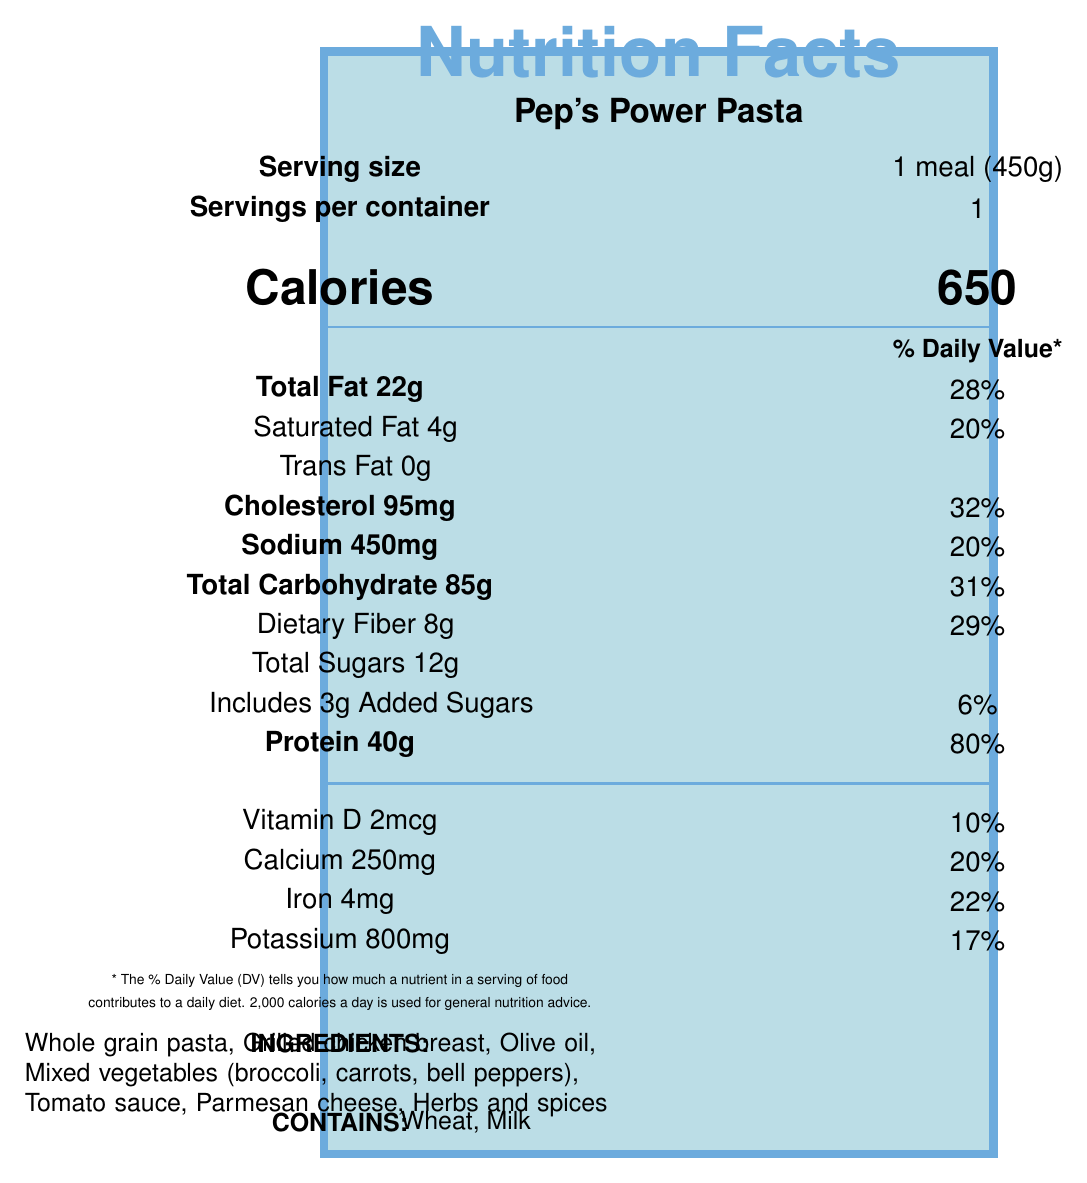what is the serving size of Pep's Power Pasta? The document specifies the serving size clearly as "1 meal (450g)".
Answer: 1 meal (450g) how many calories are in one serving of Pep's Power Pasta? The document states that one serving of this meal contains 650 calories.
Answer: 650 how much total fat does one serving of the meal contain? The total fat content per serving is listed as 22 grams.
Answer: 22 grams what percentage of the daily value for protein does this meal provide? The document indicates that the protein content of 40 grams provides an 80% daily value.
Answer: 80% which of the following is NOT an ingredient in Pep's Power Pasta? A. Olive oil B. Parmesan cheese C. Quinoa D. Grilled chicken breast The ingredients listed do not include Quinoa.
Answer: C. Quinoa what is the percentage of daily value for saturated fat in this meal? The document lists the saturated fat content at 4 grams, which corresponds to 20% of the daily value.
Answer: 20% does the meal include any added sugars? The document specifies that there are 3 grams of added sugars, contributing to 6% of the daily value.
Answer: Yes what kind of vegetables are included in the meal? The mixed vegetables in the meal include broccoli, carrots, and bell peppers as listed under the ingredients.
Answer: Mixed vegetables (broccoli, carrots, bell peppers) how much sodium is in one serving? The sodium content per serving is listed as 450mg.
Answer: 450mg which of these micronutrients provides the highest percentage of daily value? A. Vitamin D B. Calcium C. Iron D. Potassium Among the micronutrients listed, protein offers the highest percentage of daily value at 80%.
Answer: A. Protein is Pep's Power Pasta contained in more than one serving per container? The document states that there is only one serving per container.
Answer: No describe the main idea of the document The document primarily outlines the nutritional information for Pep's Power Pasta, emphasizing its purpose in fueling Manchester City players before matches.
Answer: Pep's Power Pasta is a pre-match meal designed by Manchester City's nutritionist to optimize players' energy and performance. It has balanced macronutrients including 85g of carbs, 40g of protein, and 22g of fat. The meal includes whole grain pasta, grilled chicken, vegetables, and olive oil, with allergen content in wheat and milk. what does Kevin De Bruyne say about Pep's Power Pasta? This information is found in the player testimonial section of the document.
Answer: He says it gives him the energy to dominate the midfield for a full 90 minutes and is a key part of his match day routine. how much potassium is in Pep's Power Pasta per serving? The potassium content is listed as 800mg per serving.
Answer: 800mg is the amount of trans fat in the meal higher than the amount of saturated fat? The trans fat is 0 grams, which is less than the 4 grams of saturated fat listed in the document.
Answer: No what is the main ingredient used to provide protein in the meal? The primary ingredient providing protein in this meal is grilled chicken breast as indicated in the ingredients list.
Answer: Grilled chicken breast does the meal contain any ingredients that some people are commonly allergic to? The document lists wheat and milk as allergens.
Answer: Yes what is the specific recommendation for when fans should try this meal before watching a big City match? The City Fan Tip suggests trying the meal 3-4 hours before watching a big City match.
Answer: 3-4 hours before the match what is the daily value percentage for calcium provided by this meal? The document states that the calcium content in the meal contributes to 20% of the daily value.
Answer: 20% is there any information on how this meal impacts low blood sugar levels during halftime? The document does not provide specific information regarding the meal's impact on low blood sugar levels during halftime.
Answer: Not enough information 